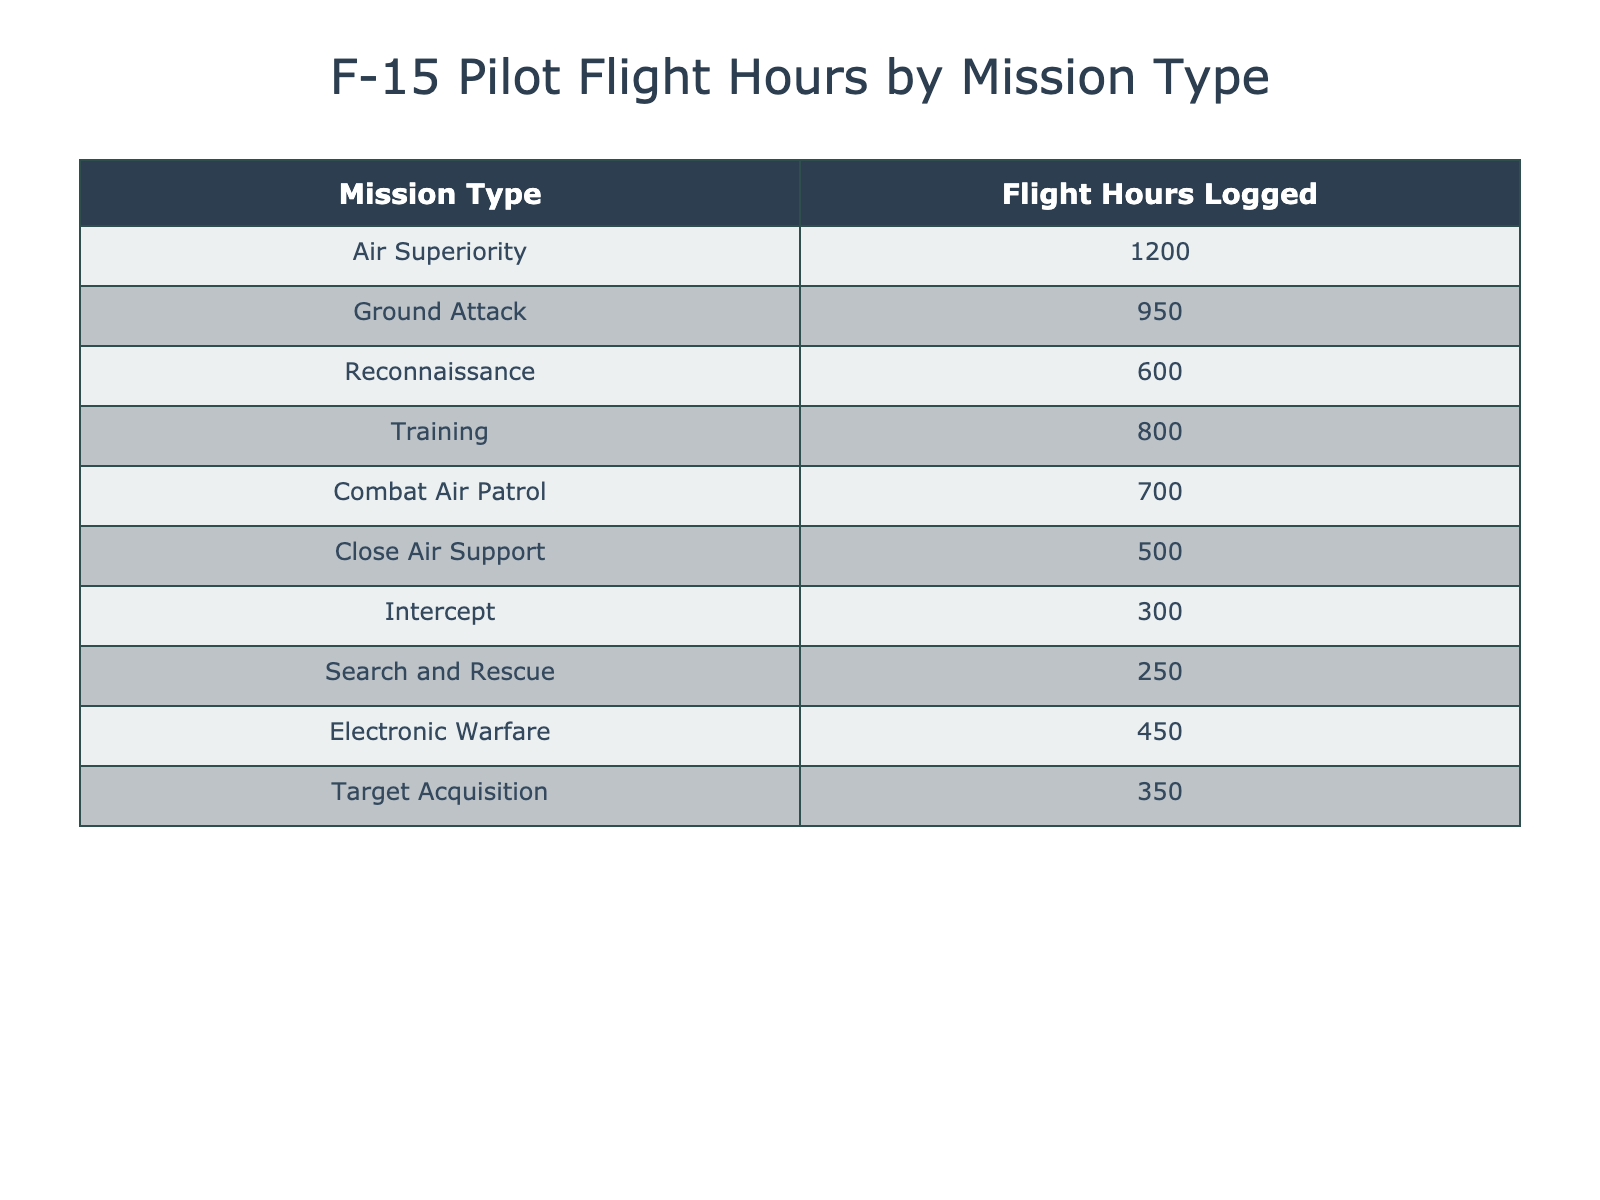What is the total number of flight hours logged by all F-15 pilots across all mission types? To find the total flight hours, we add up the flight hours for each mission type: 1200 + 950 + 600 + 800 + 700 + 500 + 300 + 250 + 450 + 350 = 5750.
Answer: 5750 Which mission type has the highest flight hours logged? The mission type with the highest flight hours logged is Air Superiority, with 1200 hours.
Answer: Air Superiority Is the total flight hours logged for Ground Attack greater than that for Training? Ground Attack has logged 950 hours, while Training has logged 800 hours. Since 950 is greater than 800, the statement is true.
Answer: Yes What is the average flight hours logged for all mission types? To find the average, sum all flight hours (5750) and divide by the number of mission types (10): 5750 / 10 = 575.
Answer: 575 How many mission types have logged more than 600 flight hours? The mission types with more than 600 flight hours are Air Superiority (1200), Ground Attack (950), Training (800), and Combat Air Patrol (700). That gives us four mission types.
Answer: 4 Is it true that the flight hours logged for Intercept is less than that for Close Air Support? Intercept logged 300 hours while Close Air Support logged 500 hours. Since 300 is indeed less than 500, the statement is true.
Answer: Yes What is the difference in flight hours logged between the mission type with the highest and the lowest hours? The highest is Air Superiority (1200 hours) and the lowest is Search and Rescue (250 hours). The difference is 1200 - 250 = 950 hours.
Answer: 950 What are the total flight hours logged by mission types that involve direct combat (Ground Attack, Close Air Support, and Intercept)? For these mission types, we sum the hours: Ground Attack (950) + Close Air Support (500) + Intercept (300) = 1750 total flight hours.
Answer: 1750 Which mission types are classified under reconnaissance activities? The only mission type classified as reconnaissance is Reconnaissance, which has 600 logged hours.
Answer: Reconnaissance How many mission types logged fewer flight hours than 500? The mission types with fewer than 500 flight hours are Intercept (300) and Search and Rescue (250), totaling two mission types.
Answer: 2 